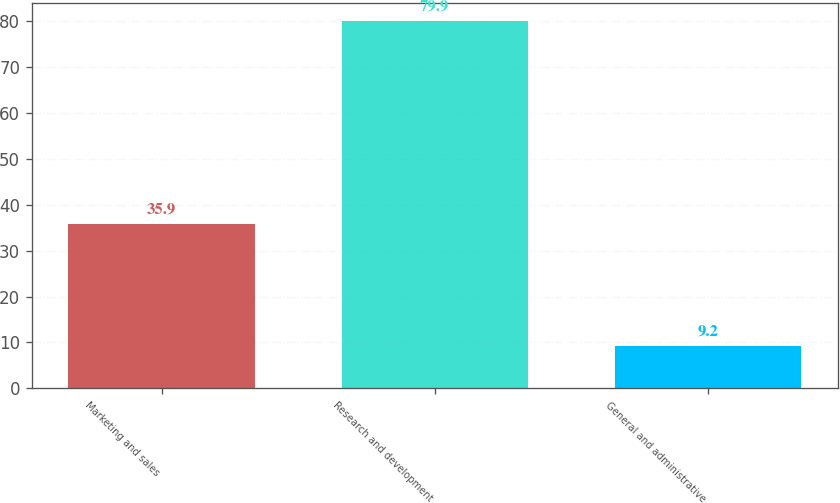Convert chart to OTSL. <chart><loc_0><loc_0><loc_500><loc_500><bar_chart><fcel>Marketing and sales<fcel>Research and development<fcel>General and administrative<nl><fcel>35.9<fcel>79.9<fcel>9.2<nl></chart> 